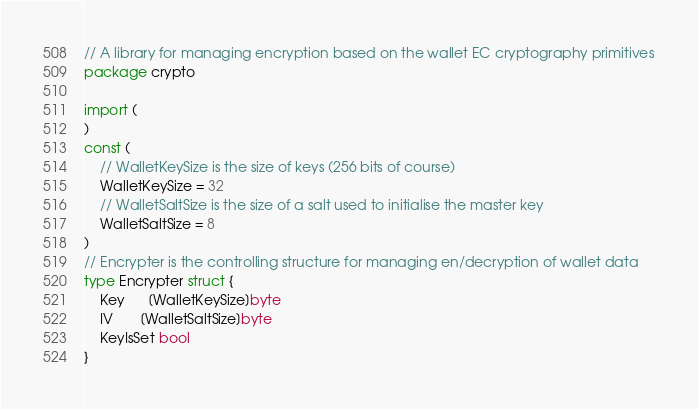Convert code to text. <code><loc_0><loc_0><loc_500><loc_500><_Go_>// A library for managing encryption based on the wallet EC cryptography primitives
package crypto

import (
)
const (
	// WalletKeySize is the size of keys (256 bits of course)
	WalletKeySize = 32
	// WalletSaltSize is the size of a salt used to initialise the master key
	WalletSaltSize = 8
)
// Encrypter is the controlling structure for managing en/decryption of wallet data
type Encrypter struct {
	Key      [WalletKeySize]byte
	IV       [WalletSaltSize]byte
	KeyIsSet bool
}
</code> 